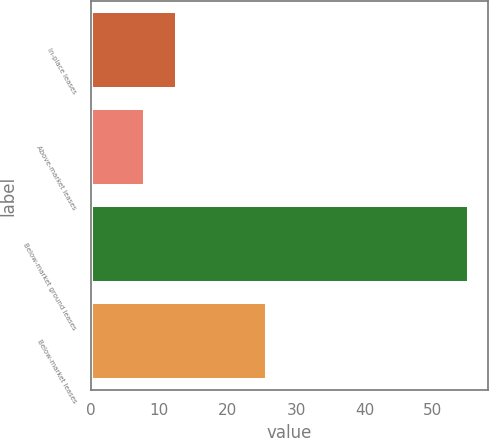Convert chart to OTSL. <chart><loc_0><loc_0><loc_500><loc_500><bar_chart><fcel>In-place leases<fcel>Above-market leases<fcel>Below-market ground leases<fcel>Below-market leases<nl><fcel>12.64<fcel>7.9<fcel>55.3<fcel>25.8<nl></chart> 